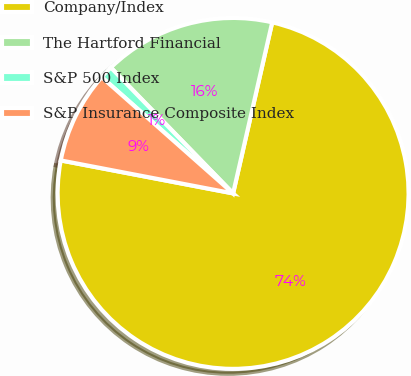Convert chart to OTSL. <chart><loc_0><loc_0><loc_500><loc_500><pie_chart><fcel>Company/Index<fcel>The Hartford Financial<fcel>S&P 500 Index<fcel>S&P Insurance Composite Index<nl><fcel>74.44%<fcel>15.85%<fcel>1.2%<fcel>8.52%<nl></chart> 